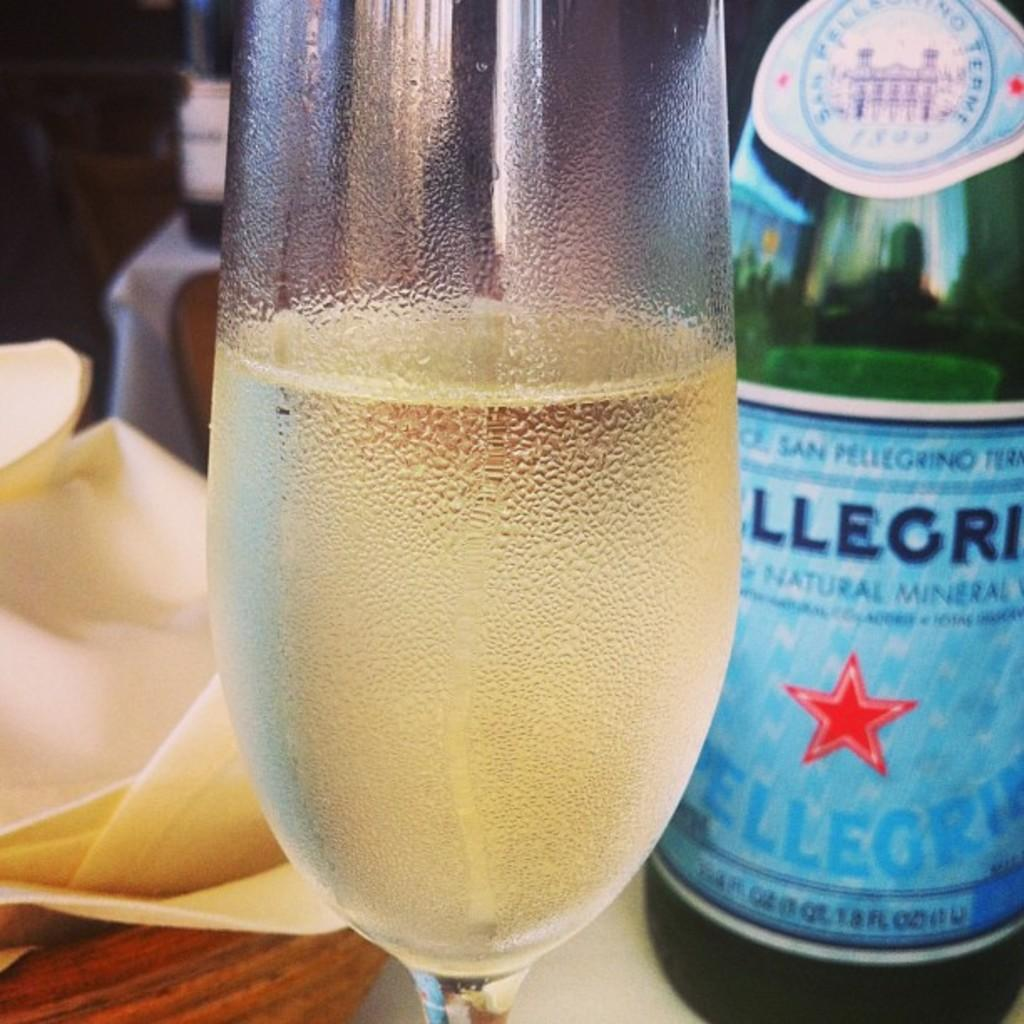<image>
Give a short and clear explanation of the subsequent image. A green bottle of pellegrino with a star in the center of the label is next to a glass full of liquid. 